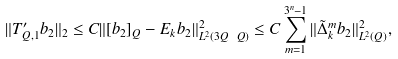Convert formula to latex. <formula><loc_0><loc_0><loc_500><loc_500>\| T ^ { \prime } _ { Q , 1 } b _ { 2 } \| _ { 2 } \leq C \| [ b _ { 2 } ] _ { Q } - E _ { k } b _ { 2 } \| ^ { 2 } _ { L ^ { 2 } ( 3 Q \ Q ) } \leq C \sum ^ { 3 ^ { n } - 1 } _ { m = 1 } \| \tilde { \Delta } ^ { m } _ { k } b _ { 2 } \| ^ { 2 } _ { L ^ { 2 } ( Q ) } ,</formula> 